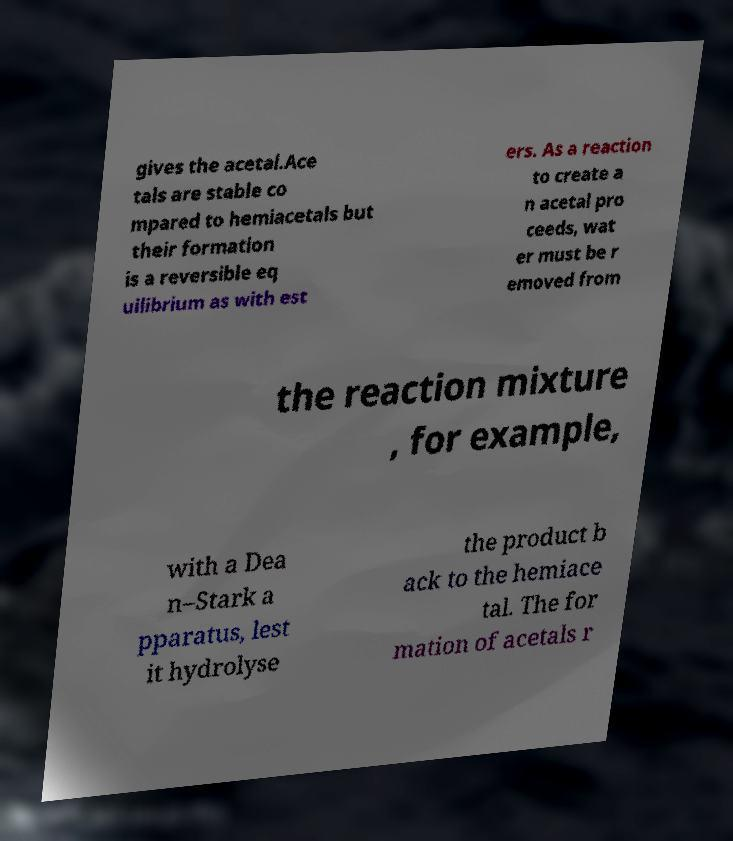Could you extract and type out the text from this image? gives the acetal.Ace tals are stable co mpared to hemiacetals but their formation is a reversible eq uilibrium as with est ers. As a reaction to create a n acetal pro ceeds, wat er must be r emoved from the reaction mixture , for example, with a Dea n–Stark a pparatus, lest it hydrolyse the product b ack to the hemiace tal. The for mation of acetals r 